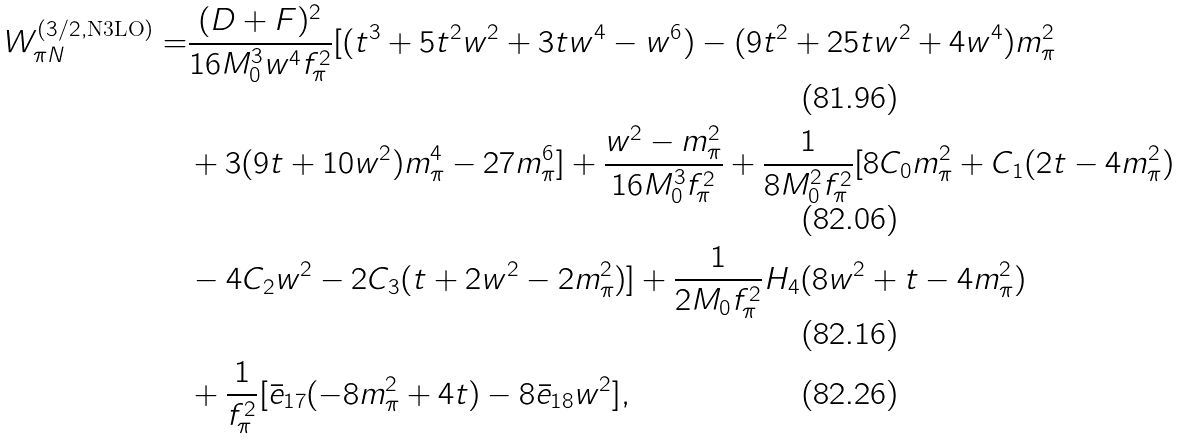<formula> <loc_0><loc_0><loc_500><loc_500>W _ { \pi N } ^ { ( 3 / 2 , \text {N3LO} ) } = & \frac { ( D + F ) ^ { 2 } } { 1 6 M _ { 0 } ^ { 3 } w ^ { 4 } f _ { \pi } ^ { 2 } } [ ( t ^ { 3 } + 5 t ^ { 2 } w ^ { 2 } + 3 t w ^ { 4 } - w ^ { 6 } ) - ( 9 t ^ { 2 } + 2 5 t w ^ { 2 } + 4 w ^ { 4 } ) m _ { \pi } ^ { 2 } \\ & + 3 ( 9 t + 1 0 w ^ { 2 } ) m _ { \pi } ^ { 4 } - 2 7 m _ { \pi } ^ { 6 } ] + \frac { w ^ { 2 } - m _ { \pi } ^ { 2 } } { 1 6 M _ { 0 } ^ { 3 } f _ { \pi } ^ { 2 } } + \frac { 1 } { 8 M _ { 0 } ^ { 2 } f _ { \pi } ^ { 2 } } [ 8 C _ { 0 } m _ { \pi } ^ { 2 } + C _ { 1 } ( 2 t - 4 m _ { \pi } ^ { 2 } ) \\ & - 4 C _ { 2 } w ^ { 2 } - 2 C _ { 3 } ( t + 2 w ^ { 2 } - 2 m _ { \pi } ^ { 2 } ) ] + \frac { 1 } { 2 M _ { 0 } f _ { \pi } ^ { 2 } } H _ { 4 } ( 8 w ^ { 2 } + t - 4 m _ { \pi } ^ { 2 } ) \\ & + \frac { 1 } { f _ { \pi } ^ { 2 } } [ \bar { e } _ { 1 7 } ( - 8 m _ { \pi } ^ { 2 } + 4 t ) - 8 \bar { e } _ { 1 8 } w ^ { 2 } ] ,</formula> 